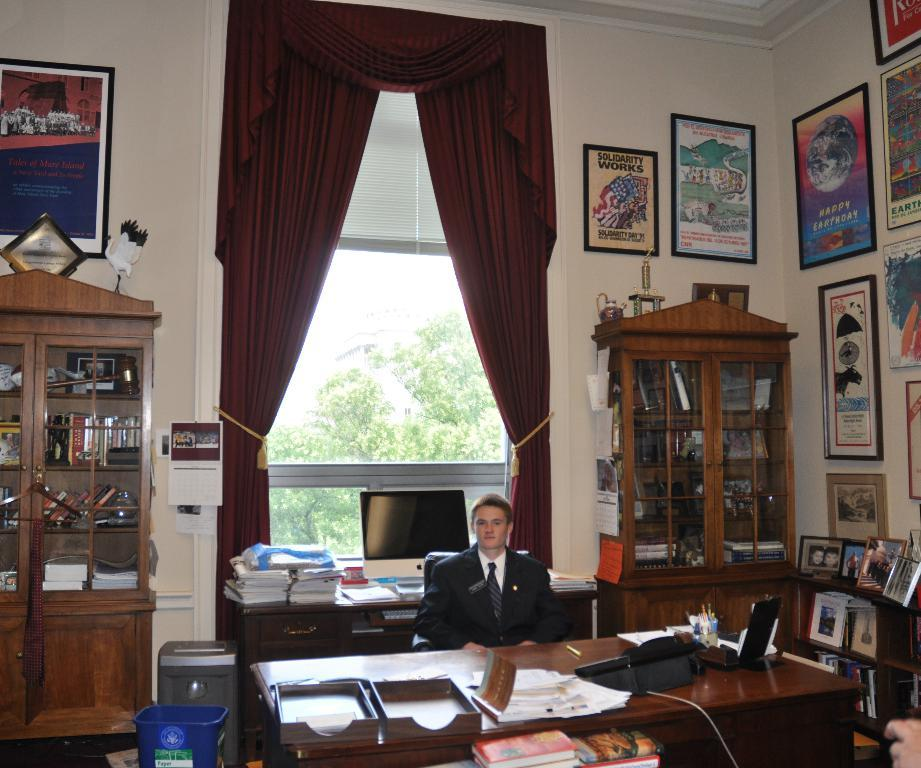Provide a one-sentence caption for the provided image. A framed poster high on an office wall proclaims that Solidarity Works. 